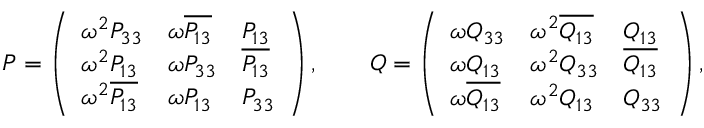<formula> <loc_0><loc_0><loc_500><loc_500>\begin{array} { r l } & { P = \left ( \begin{array} { l l l } { \omega ^ { 2 } P _ { 3 3 } } & { \omega \overline { { P _ { 1 3 } } } } & { P _ { 1 3 } } \\ { \omega ^ { 2 } P _ { 1 3 } } & { \omega P _ { 3 3 } } & { \overline { { P _ { 1 3 } } } } \\ { \omega ^ { 2 } \overline { { P _ { 1 3 } } } } & { \omega P _ { 1 3 } } & { P _ { 3 3 } } \end{array} \right ) , \quad Q = \left ( \begin{array} { l l l } { \omega Q _ { 3 3 } } & { \omega ^ { 2 } \overline { { Q _ { 1 3 } } } } & { Q _ { 1 3 } } \\ { \omega Q _ { 1 3 } } & { \omega ^ { 2 } Q _ { 3 3 } } & { \overline { { Q _ { 1 3 } } } } \\ { \omega \overline { { Q _ { 1 3 } } } } & { \omega ^ { 2 } Q _ { 1 3 } } & { Q _ { 3 3 } } \end{array} \right ) , } \end{array}</formula> 